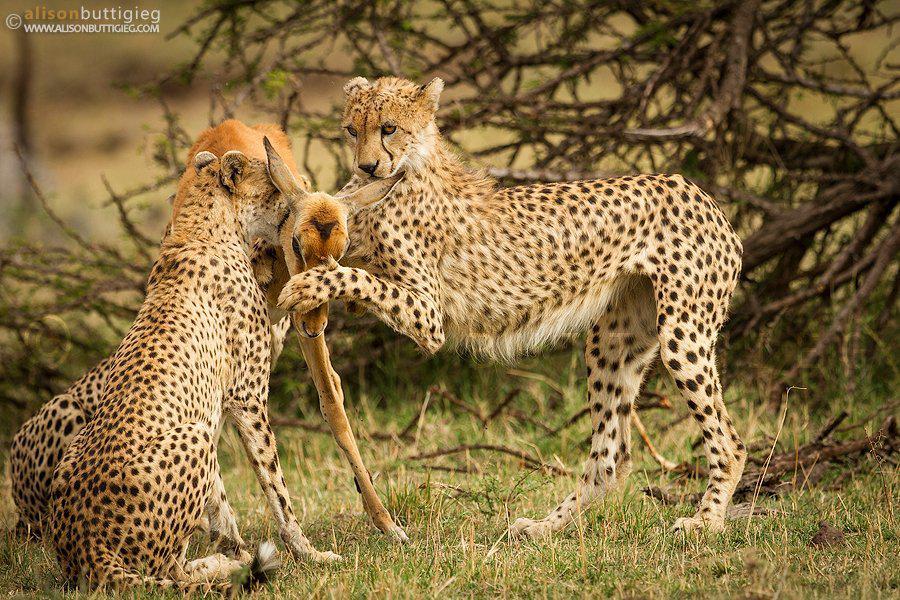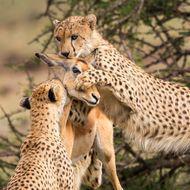The first image is the image on the left, the second image is the image on the right. For the images shown, is this caption "A cheetah's paw is on a deer's face in at last one of the images." true? Answer yes or no. Yes. 